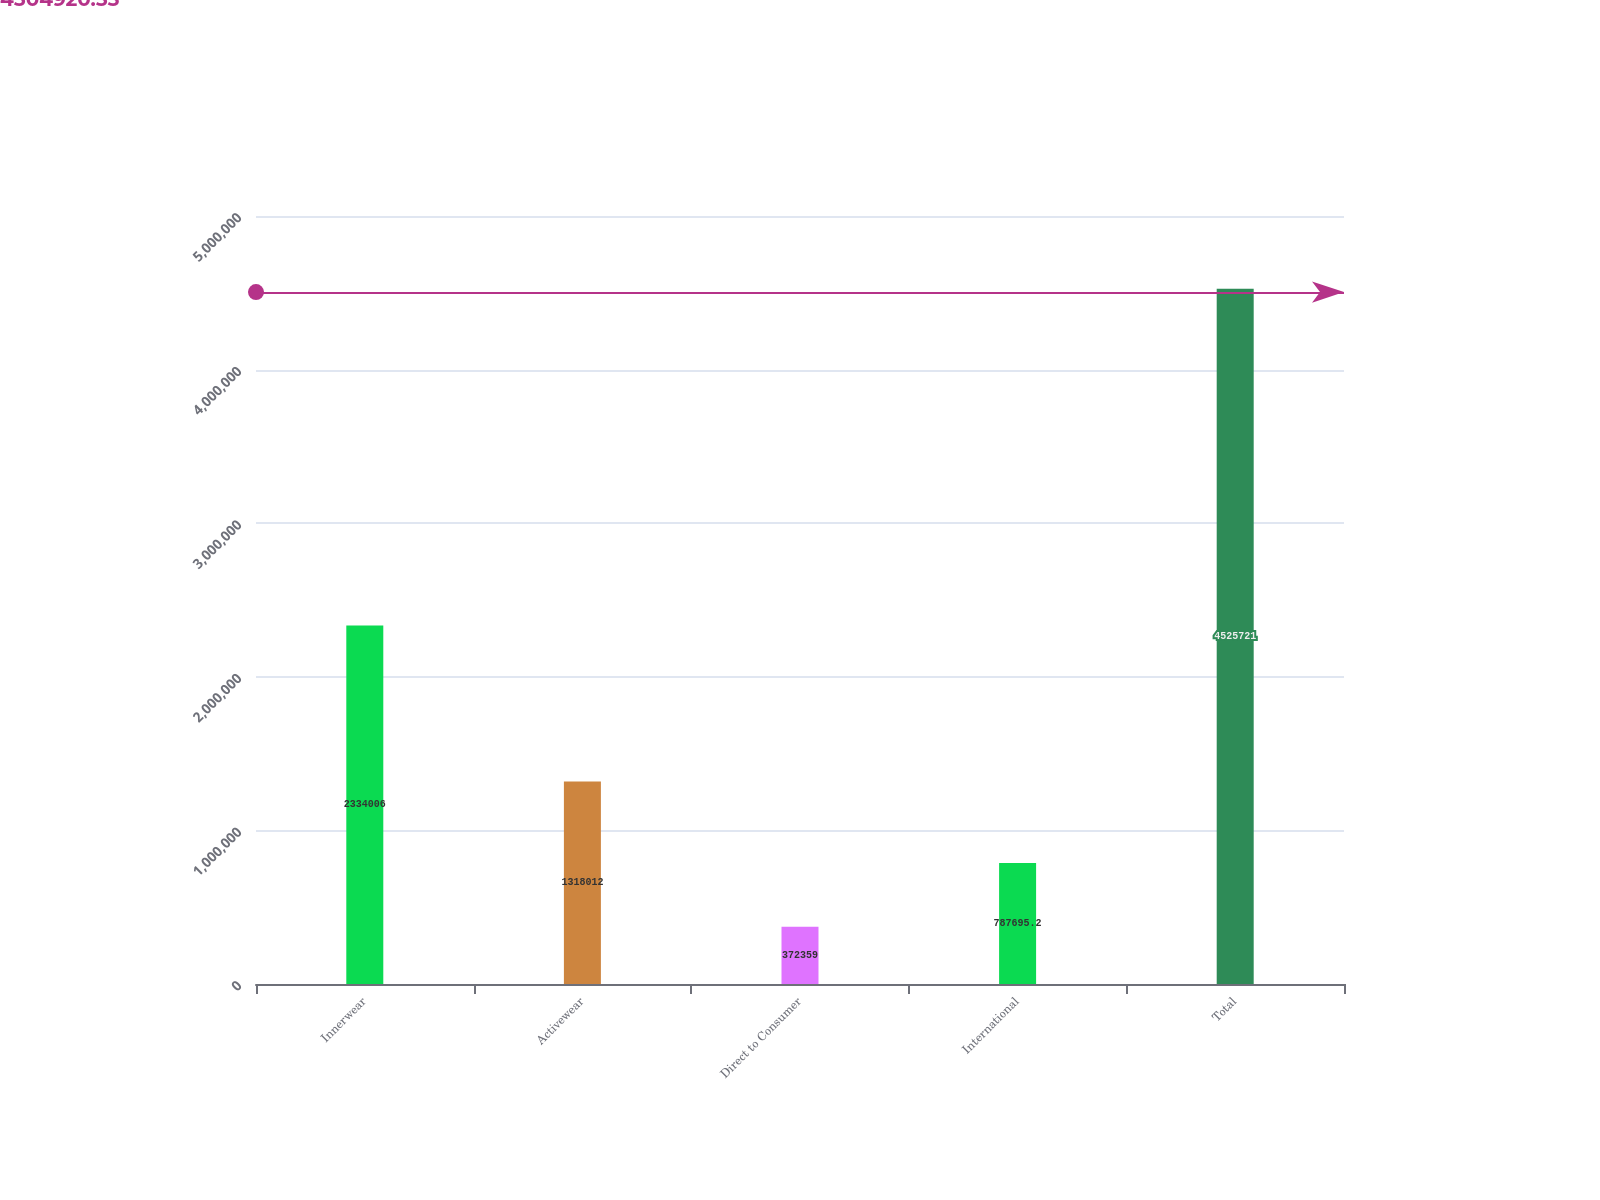Convert chart. <chart><loc_0><loc_0><loc_500><loc_500><bar_chart><fcel>Innerwear<fcel>Activewear<fcel>Direct to Consumer<fcel>International<fcel>Total<nl><fcel>2.33401e+06<fcel>1.31801e+06<fcel>372359<fcel>787695<fcel>4.52572e+06<nl></chart> 